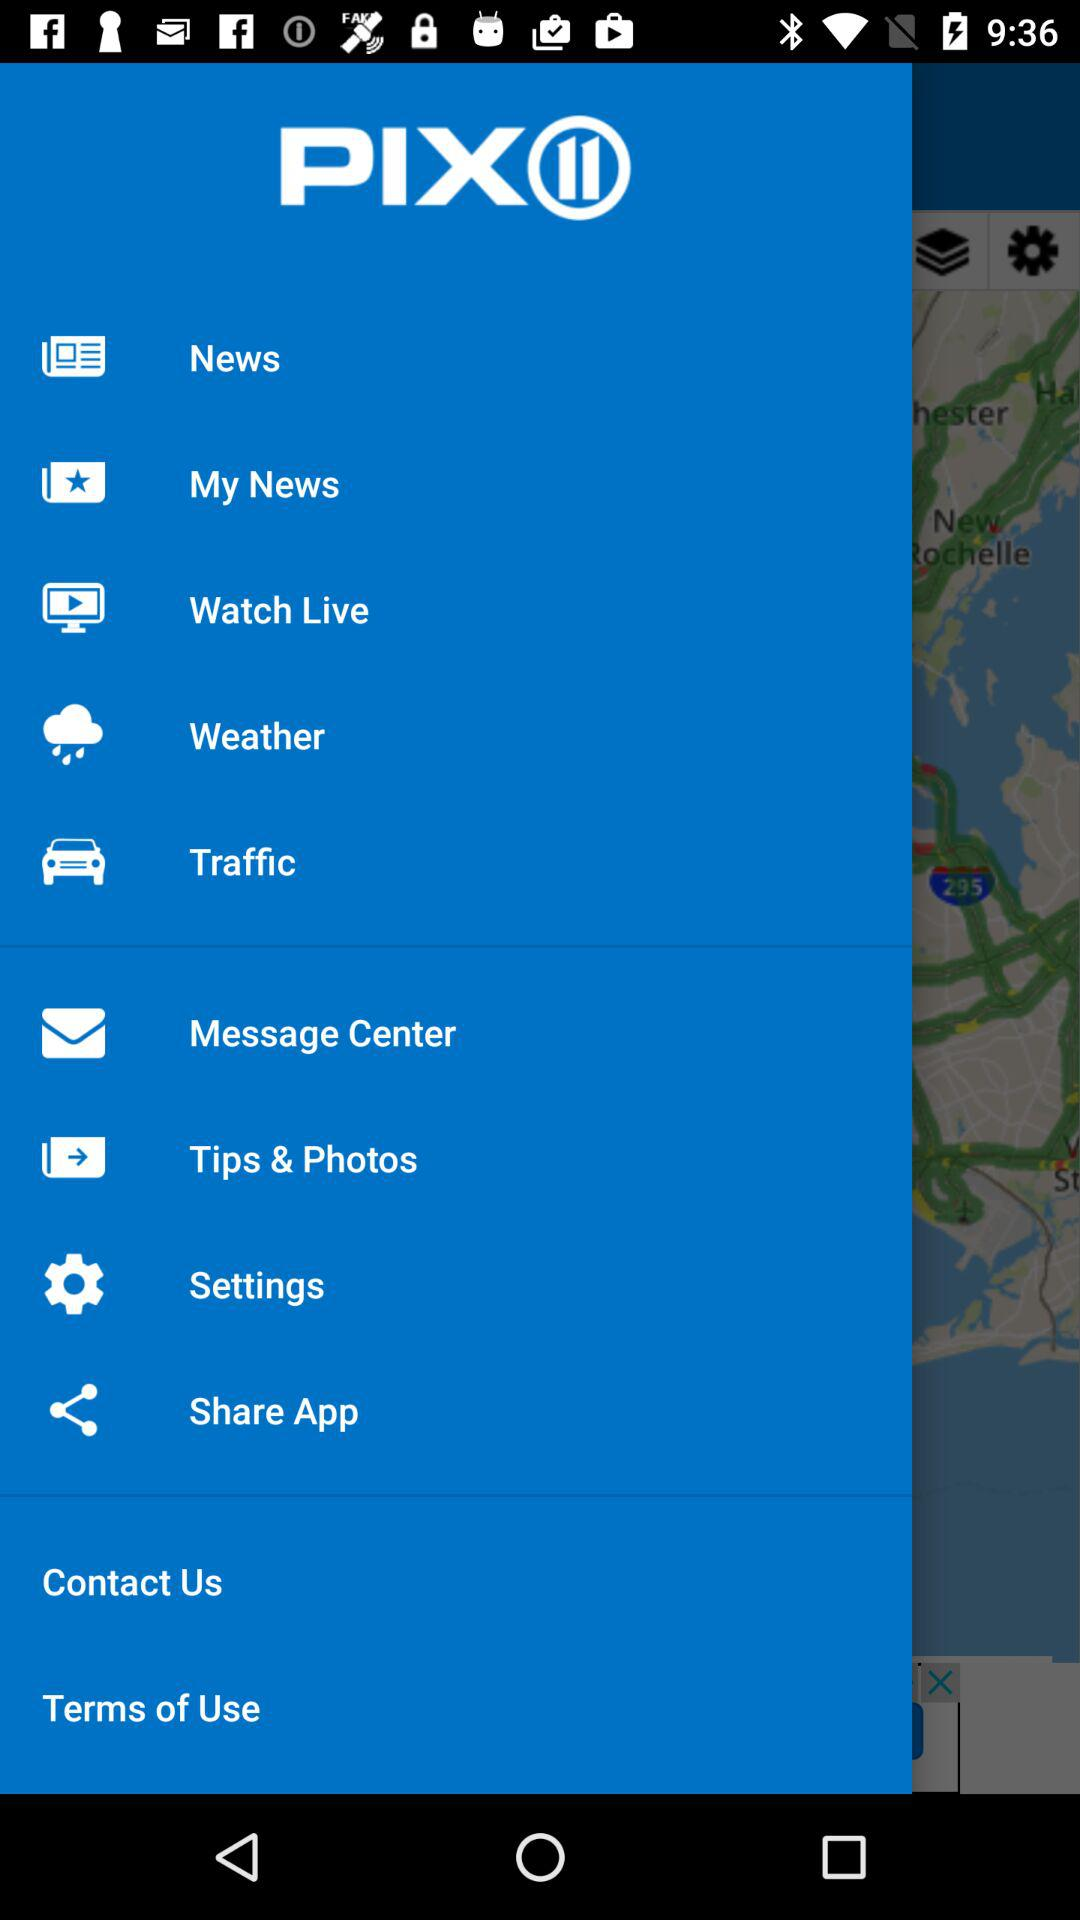What is the application name? The application name is "PIX⑪". 